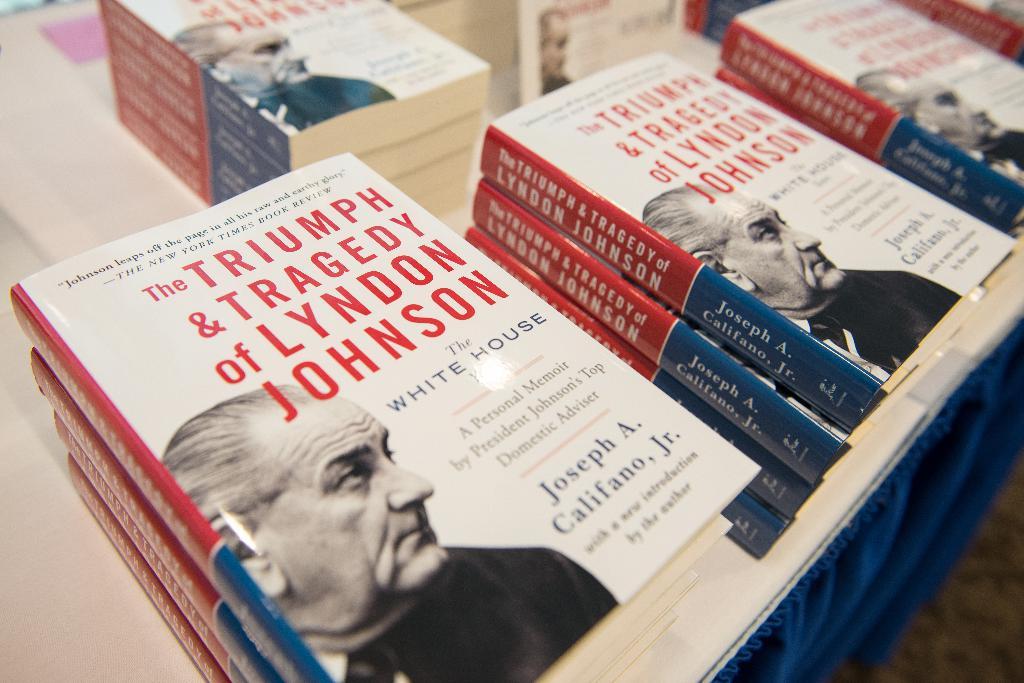Who is the author of the book?
Give a very brief answer. Joseph a. califano, jr. What is the title of the book?
Ensure brevity in your answer.  The triumph & tragedy of lyndon johnson. 